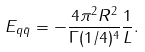Convert formula to latex. <formula><loc_0><loc_0><loc_500><loc_500>E _ { q \bar { q } } = - \frac { 4 \pi ^ { 2 } R ^ { 2 } } { \Gamma ( 1 / 4 ) ^ { 4 } } \frac { 1 } { L } .</formula> 